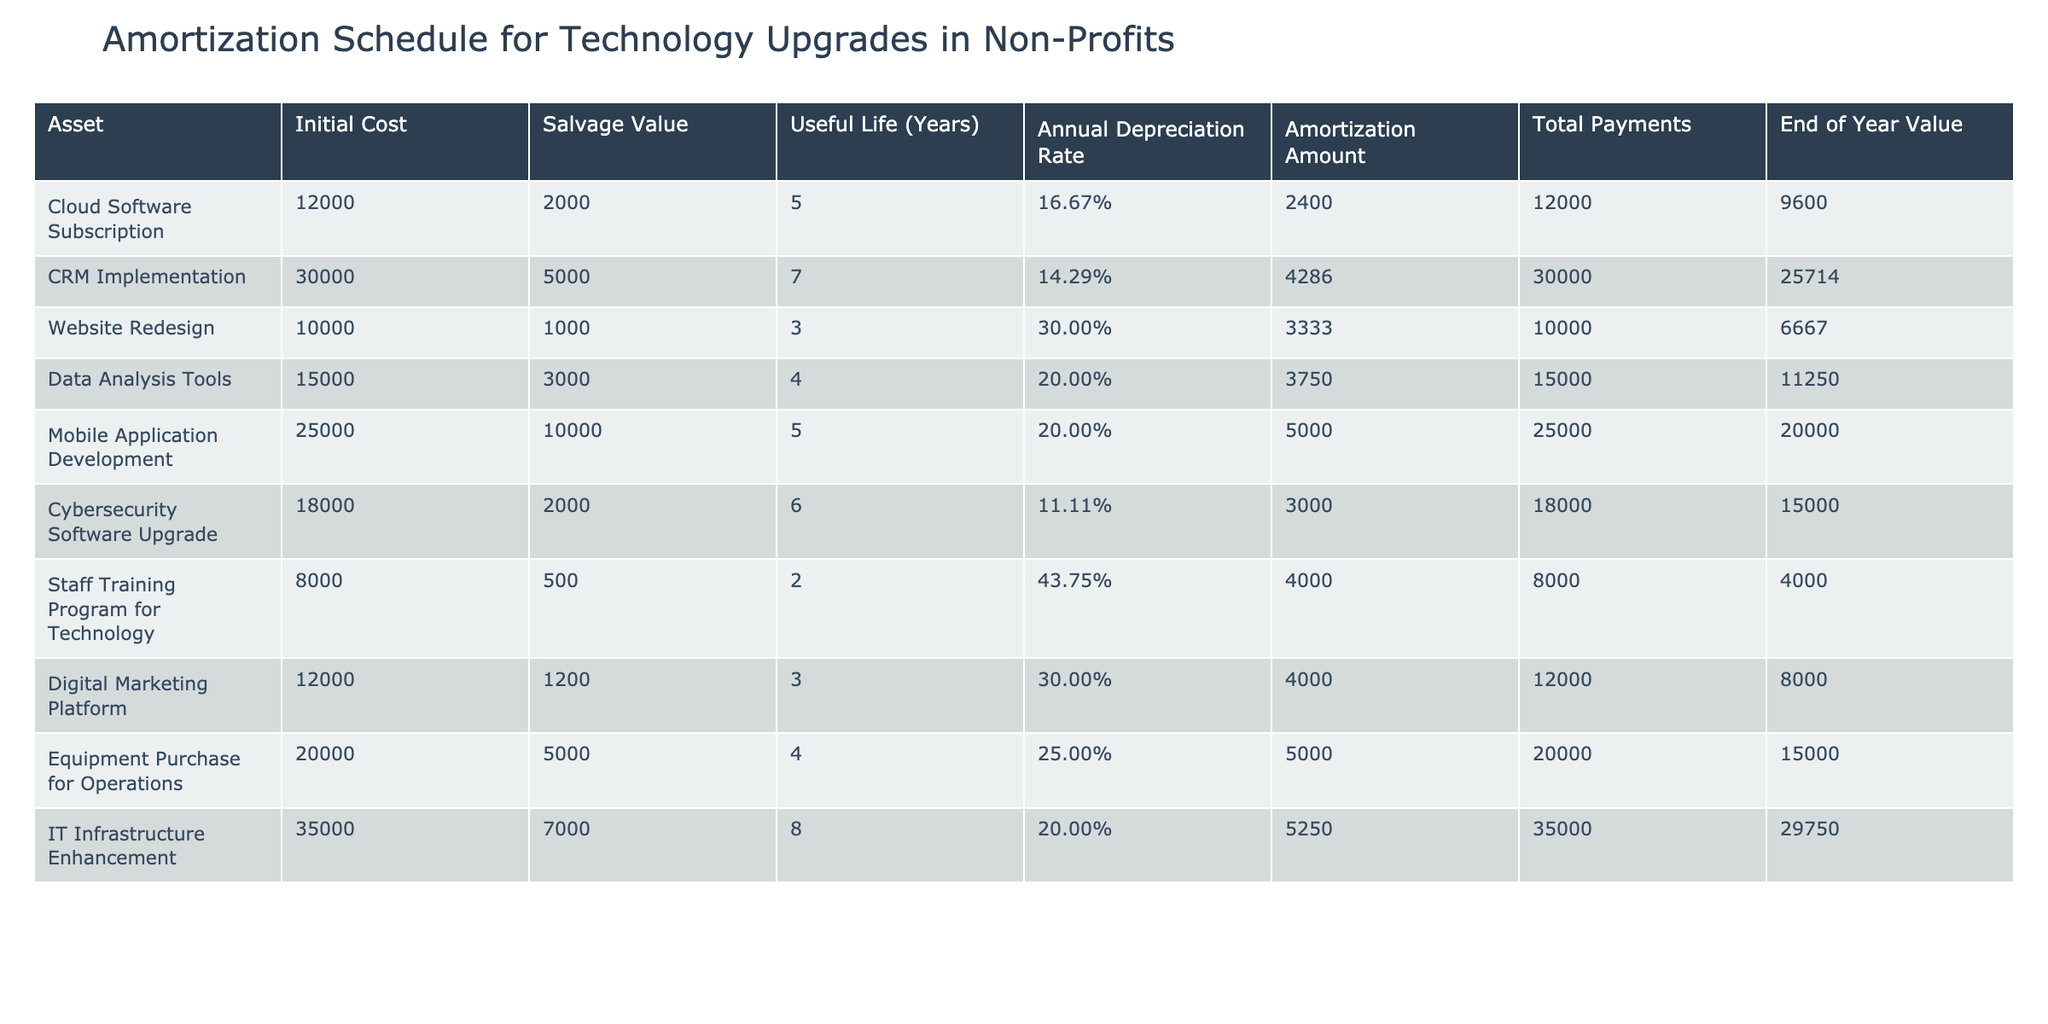What is the annual depreciation rate for the Data Analysis Tools? The table specifies the annual depreciation rate for Data Analysis Tools in the column labeled "Annual Depreciation Rate." This value is listed directly as 20.00%.
Answer: 20.00% How much will the organization spend in total on the CRM Implementation? The total payments for the CRM Implementation are shown in the column labeled "Total Payments." The value is listed as 30000.
Answer: 30000 Is the salvage value of the Cloud Software Subscription greater than the salvage value of the Cybersecurity Software Upgrade? The salvage value for the Cloud Software Subscription is 2000, while for the Cybersecurity Software Upgrade, it is also 2000. Since both values are equal, the answer is no.
Answer: No What is the end of year value of the Mobile Application Development asset? The end of year value for Mobile Application Development can be found in the column labeled "End of Year Value." It is indicated as 20000.
Answer: 20000 Which asset has the highest annual depreciation amount, and what is that amount? By examining the "Amortization Amount" column, we can see that the Staff Training Program for Technology has the highest value of 4000, compared to others.
Answer: Staff Training Program for Technology, 4000 What is the average annual depreciation amount across all assets listed in the table? To find the average, we sum all amortization amounts: (2400 + 4286 + 3333 + 3750 + 5000 + 3000 + 4000 + 4000 + 5000 + 5250) = 25019. There are 10 assets, so the average is 25019/10 = 2501.90.
Answer: 2501.90 Is the useful life of the Digital Marketing Platform shorter than the useful life of the Equipment Purchase for Operations? The useful life of the Digital Marketing Platform is 3 years, whereas the Equipment Purchase for Operations has a useful life of 4 years. Since 3 is less than 4, the answer is yes.
Answer: Yes What total depreciation value will be received from the Website Redesign at the end of its useful life? For the Website Redesign asset, the total depreciation can be found by multiplying the annual depreciation amount (3333) by the useful life (3 years), giving us 3333 * 3 = 9999.
Answer: 9999 Which technology upgrade has the longest useful life, and how long is that? By looking at the "Useful Life (Years)" column, we can see that IT Infrastructure Enhancement has the longest duration at 8 years.
Answer: IT Infrastructure Enhancement, 8 years 